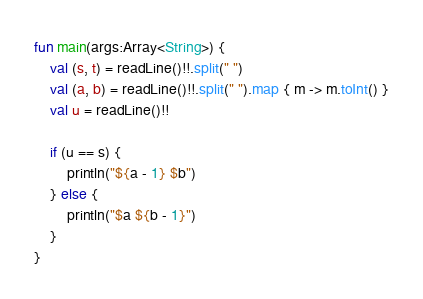<code> <loc_0><loc_0><loc_500><loc_500><_Kotlin_>fun main(args:Array<String>) {
    val (s, t) = readLine()!!.split(" ")
    val (a, b) = readLine()!!.split(" ").map { m -> m.toInt() }
    val u = readLine()!!
    
    if (u == s) {
        println("${a - 1} $b")
    } else {
        println("$a ${b - 1}")
    }
}</code> 